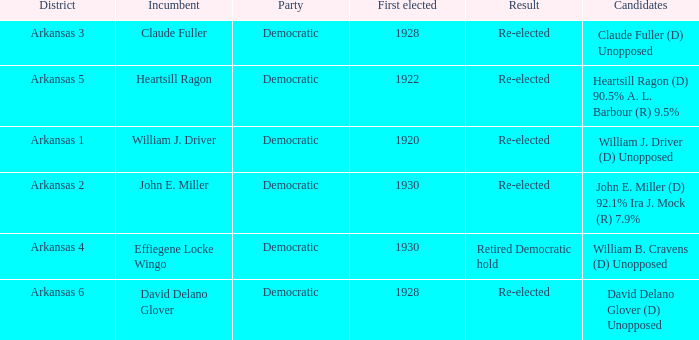In what district was John E. Miller the incumbent?  Arkansas 2. 